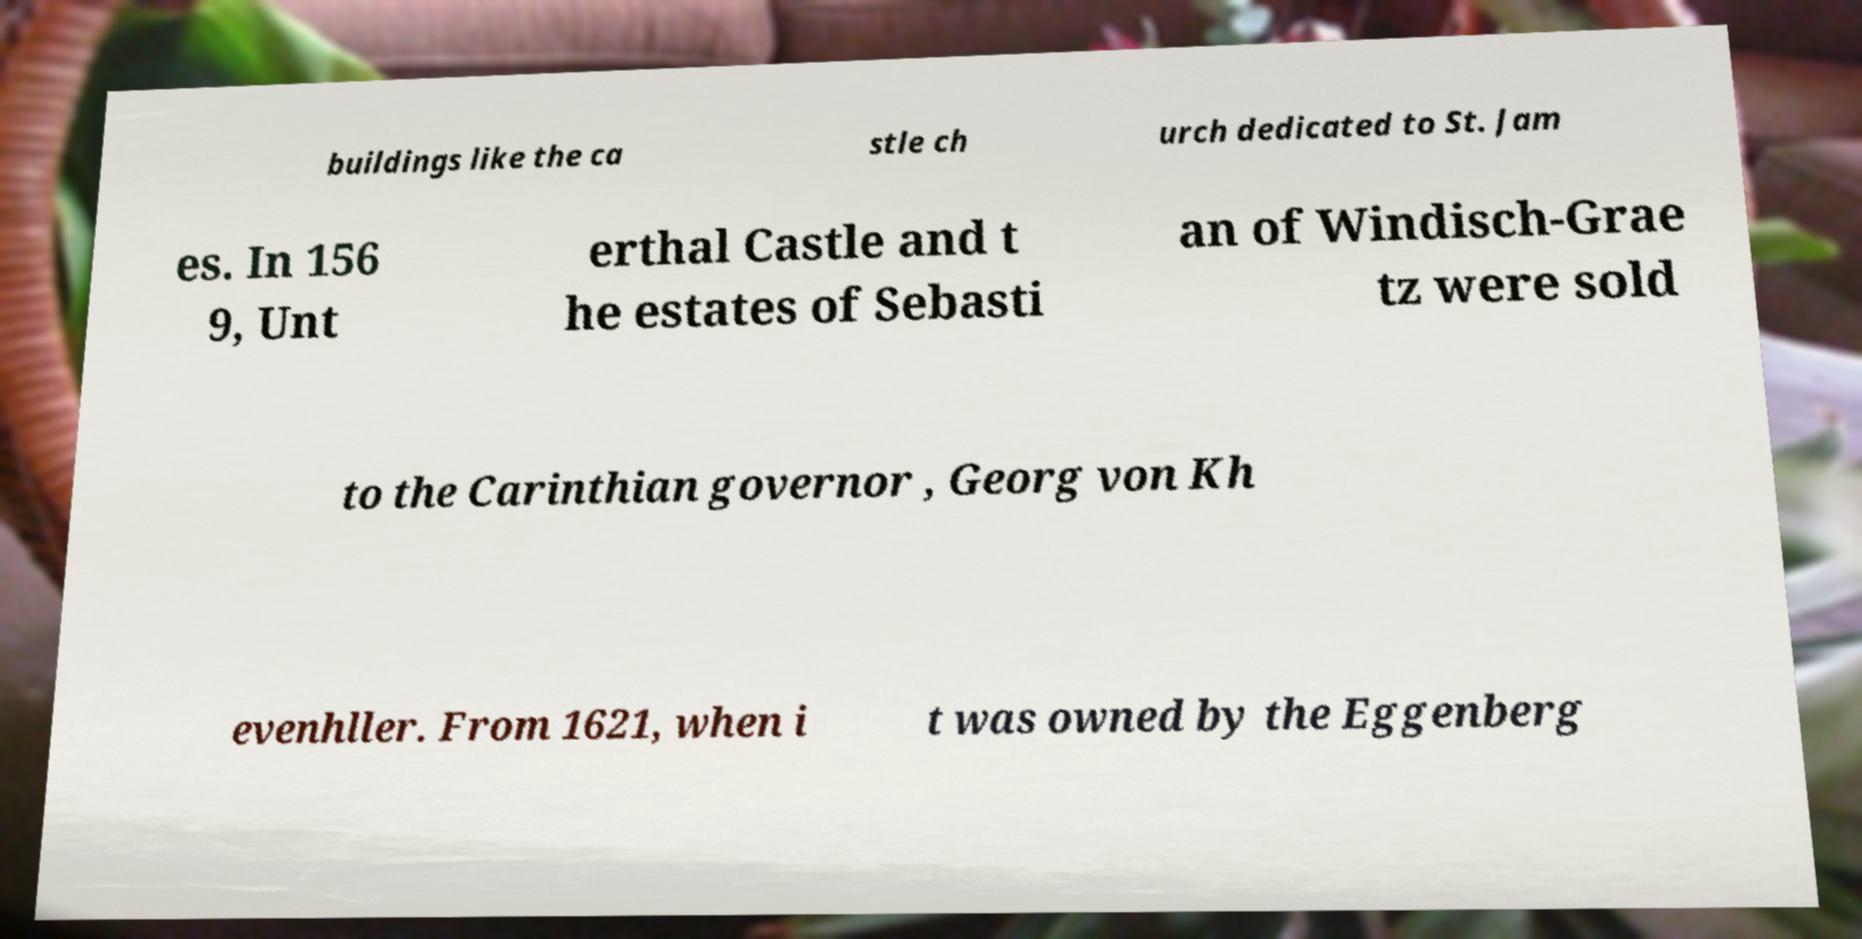There's text embedded in this image that I need extracted. Can you transcribe it verbatim? buildings like the ca stle ch urch dedicated to St. Jam es. In 156 9, Unt erthal Castle and t he estates of Sebasti an of Windisch-Grae tz were sold to the Carinthian governor , Georg von Kh evenhller. From 1621, when i t was owned by the Eggenberg 